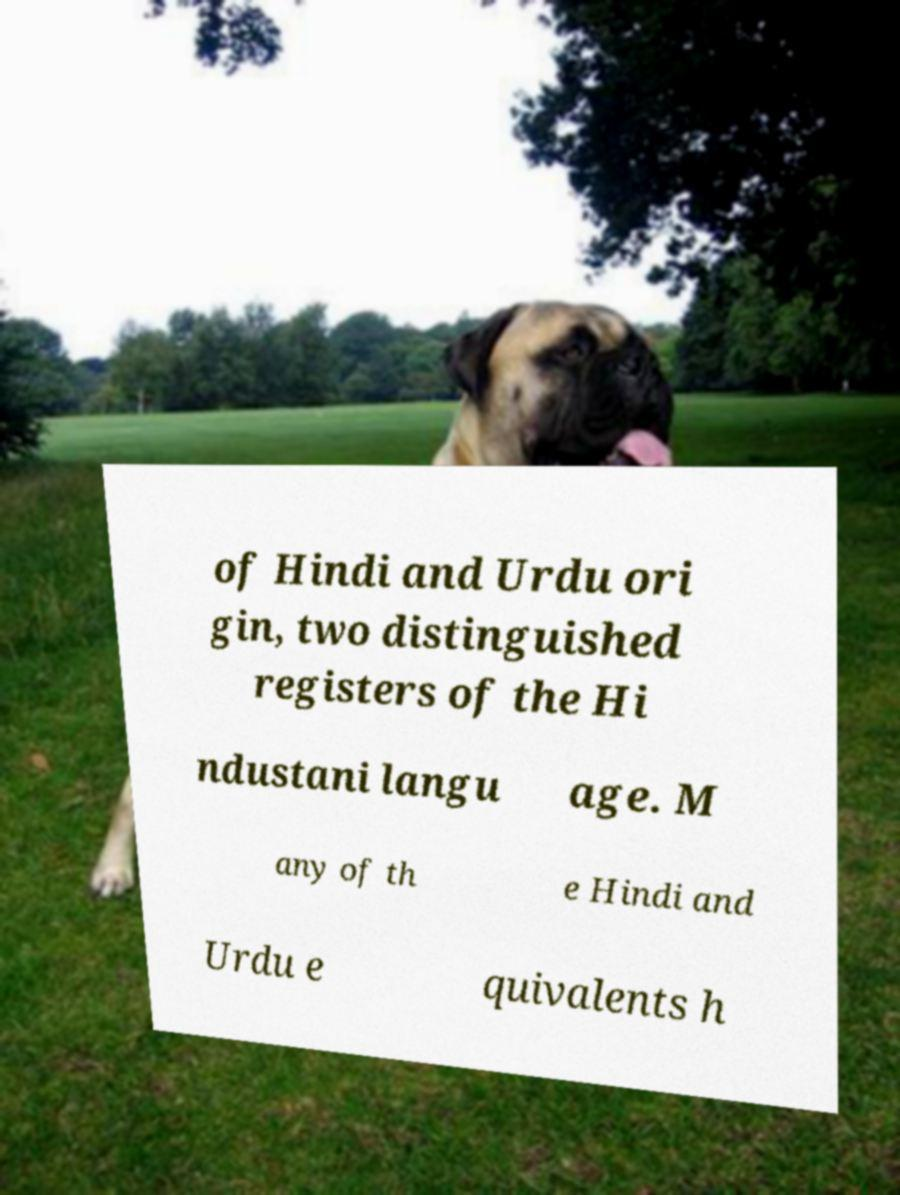Can you accurately transcribe the text from the provided image for me? of Hindi and Urdu ori gin, two distinguished registers of the Hi ndustani langu age. M any of th e Hindi and Urdu e quivalents h 